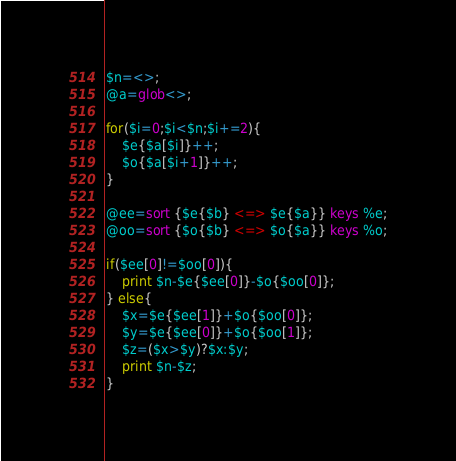Convert code to text. <code><loc_0><loc_0><loc_500><loc_500><_Perl_>$n=<>;
@a=glob<>;

for($i=0;$i<$n;$i+=2){
    $e{$a[$i]}++;
    $o{$a[$i+1]}++;
}

@ee=sort {$e{$b} <=> $e{$a}} keys %e;
@oo=sort {$o{$b} <=> $o{$a}} keys %o;

if($ee[0]!=$oo[0]){
    print $n-$e{$ee[0]}-$o{$oo[0]};
} else{
    $x=$e{$ee[1]}+$o{$oo[0]};
    $y=$e{$ee[0]}+$o{$oo[1]};
    $z=($x>$y)?$x:$y;
    print $n-$z;
}
</code> 